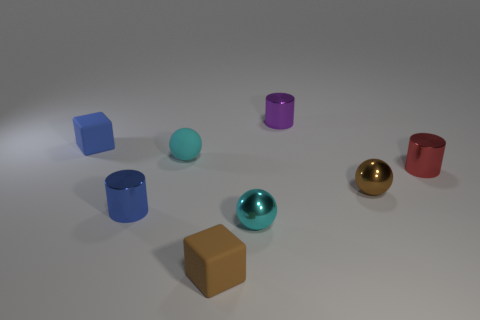Subtract all gray blocks. How many cyan balls are left? 2 Subtract all tiny cyan spheres. How many spheres are left? 1 Subtract 1 cylinders. How many cylinders are left? 2 Add 2 blue objects. How many objects exist? 10 Subtract all balls. How many objects are left? 5 Add 1 small blue shiny cylinders. How many small blue shiny cylinders exist? 2 Subtract 1 brown blocks. How many objects are left? 7 Subtract all small gray metallic objects. Subtract all tiny red metallic objects. How many objects are left? 7 Add 7 blue cylinders. How many blue cylinders are left? 8 